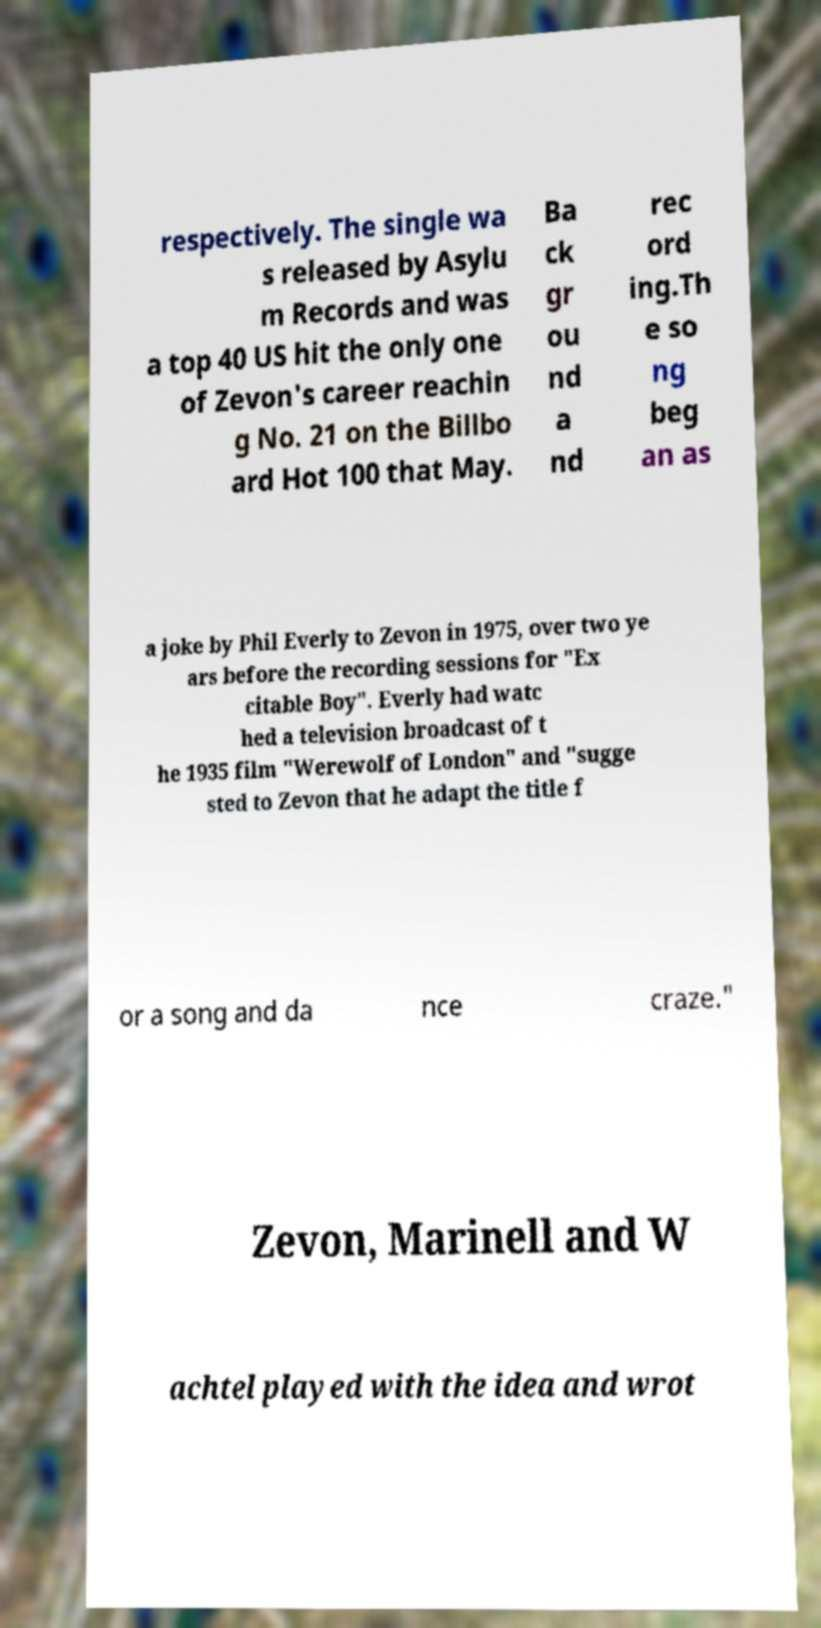Please identify and transcribe the text found in this image. respectively. The single wa s released by Asylu m Records and was a top 40 US hit the only one of Zevon's career reachin g No. 21 on the Billbo ard Hot 100 that May. Ba ck gr ou nd a nd rec ord ing.Th e so ng beg an as a joke by Phil Everly to Zevon in 1975, over two ye ars before the recording sessions for "Ex citable Boy". Everly had watc hed a television broadcast of t he 1935 film "Werewolf of London" and "sugge sted to Zevon that he adapt the title f or a song and da nce craze." Zevon, Marinell and W achtel played with the idea and wrot 